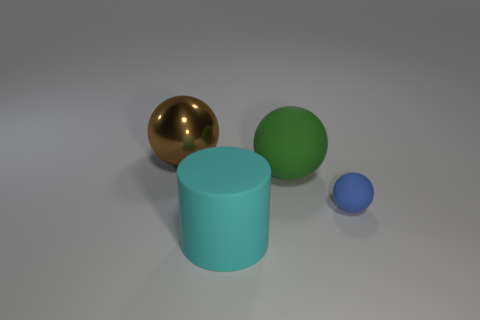Are there any other things that have the same size as the blue matte object?
Your answer should be compact. No. Is there a green object of the same size as the matte cylinder?
Make the answer very short. Yes. How many objects are spheres behind the tiny blue matte sphere or tiny cyan metal things?
Keep it short and to the point. 2. Is the material of the green sphere the same as the thing left of the large rubber cylinder?
Your response must be concise. No. How many other objects are the same shape as the green matte thing?
Provide a succinct answer. 2. How many objects are either balls to the left of the green rubber thing or large balls to the right of the big brown shiny ball?
Your response must be concise. 2. How many other objects are there of the same color as the large shiny thing?
Provide a short and direct response. 0. Is the number of small blue balls in front of the small rubber ball less than the number of large green matte things in front of the cyan cylinder?
Ensure brevity in your answer.  No. How many big spheres are there?
Make the answer very short. 2. Are there any other things that have the same material as the big brown thing?
Your response must be concise. No. 